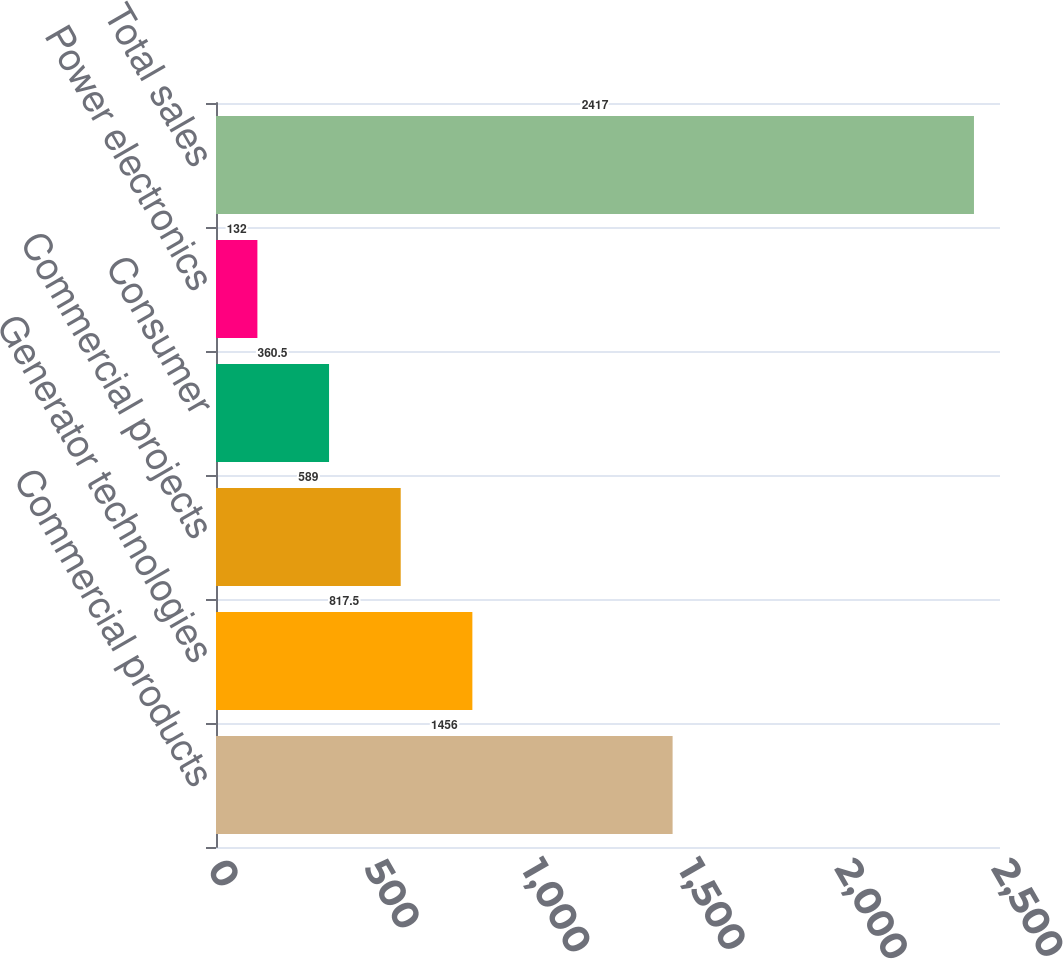Convert chart. <chart><loc_0><loc_0><loc_500><loc_500><bar_chart><fcel>Commercial products<fcel>Generator technologies<fcel>Commercial projects<fcel>Consumer<fcel>Power electronics<fcel>Total sales<nl><fcel>1456<fcel>817.5<fcel>589<fcel>360.5<fcel>132<fcel>2417<nl></chart> 